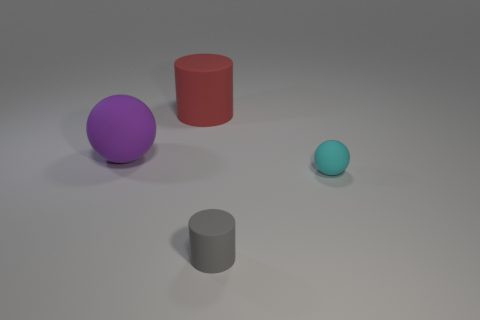Add 4 cylinders. How many objects exist? 8 Subtract 0 gray cubes. How many objects are left? 4 Subtract all big brown cubes. Subtract all purple rubber things. How many objects are left? 3 Add 4 big red things. How many big red things are left? 5 Add 4 gray cylinders. How many gray cylinders exist? 5 